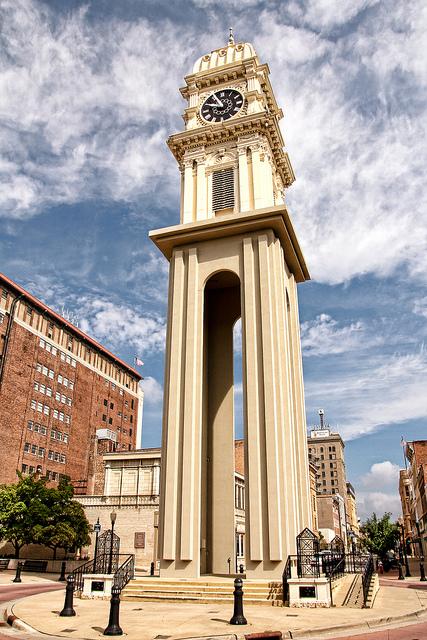Are the black things around the clock parking meters?
Answer briefly. No. How high up is the clock?
Give a very brief answer. 100 feet. Do you see any people walking under the clock?
Give a very brief answer. No. 